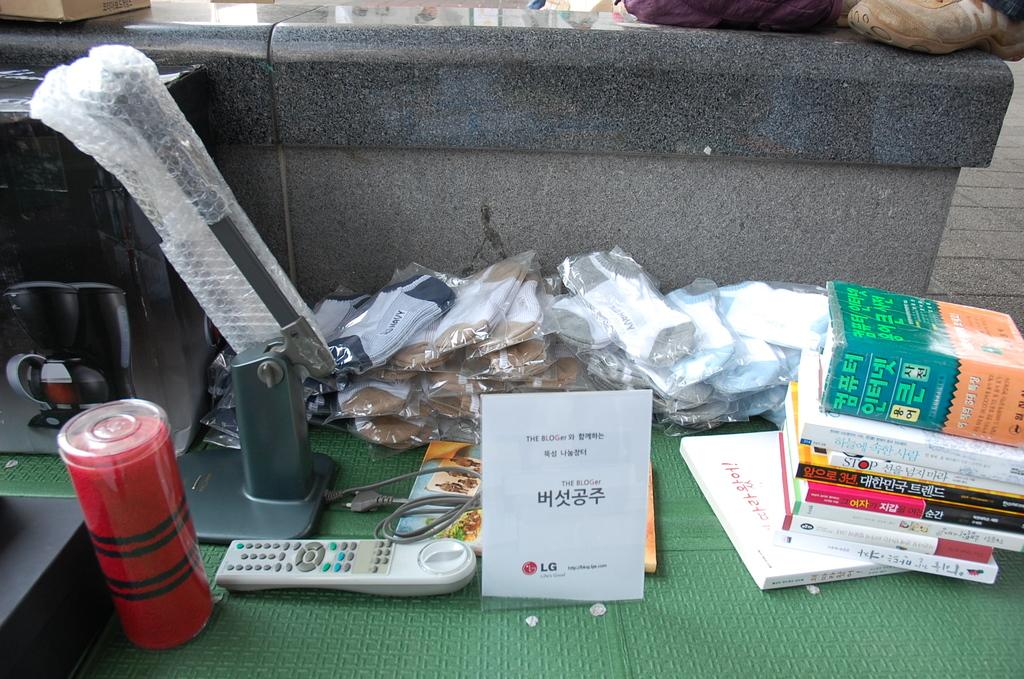<image>
Describe the image concisely. A few books and other items such as a remote, one of the books is called Stop. 